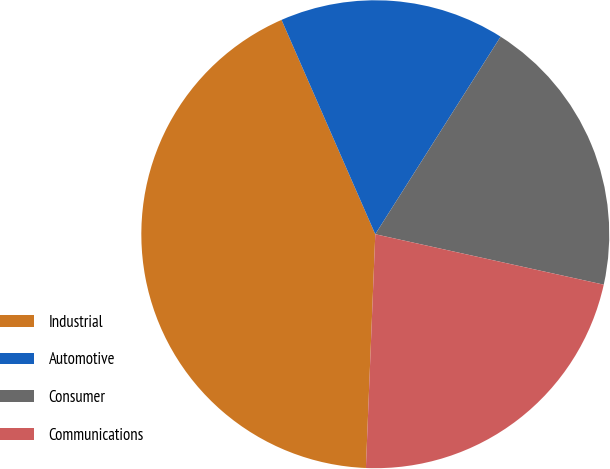<chart> <loc_0><loc_0><loc_500><loc_500><pie_chart><fcel>Industrial<fcel>Automotive<fcel>Consumer<fcel>Communications<nl><fcel>42.8%<fcel>15.56%<fcel>19.46%<fcel>22.18%<nl></chart> 